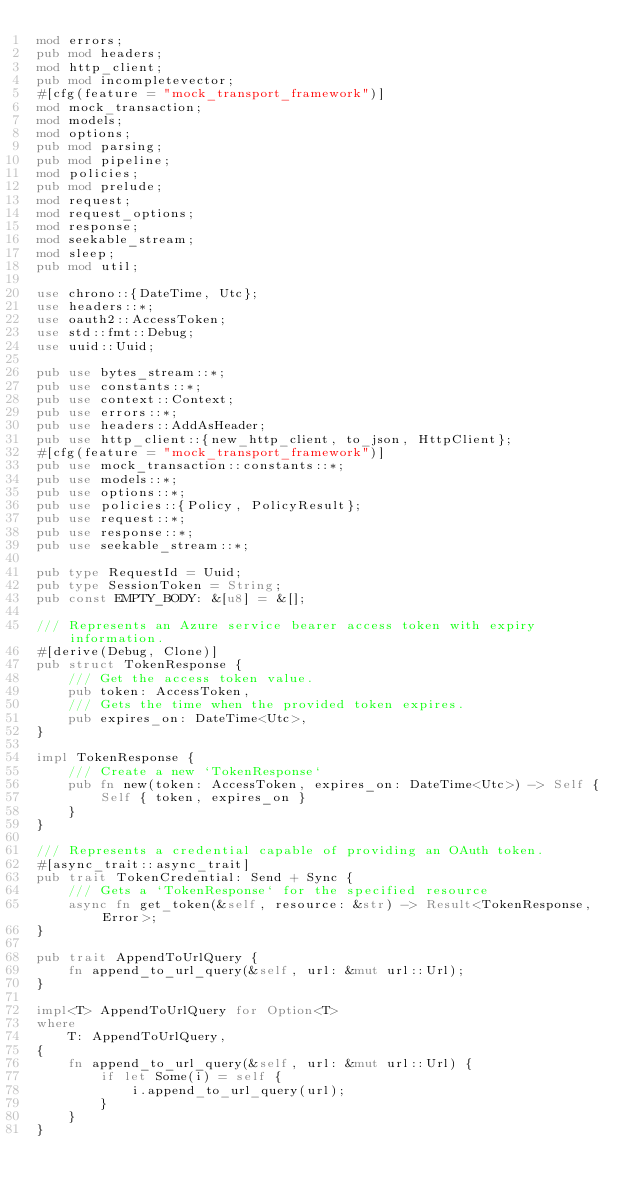<code> <loc_0><loc_0><loc_500><loc_500><_Rust_>mod errors;
pub mod headers;
mod http_client;
pub mod incompletevector;
#[cfg(feature = "mock_transport_framework")]
mod mock_transaction;
mod models;
mod options;
pub mod parsing;
pub mod pipeline;
mod policies;
pub mod prelude;
mod request;
mod request_options;
mod response;
mod seekable_stream;
mod sleep;
pub mod util;

use chrono::{DateTime, Utc};
use headers::*;
use oauth2::AccessToken;
use std::fmt::Debug;
use uuid::Uuid;

pub use bytes_stream::*;
pub use constants::*;
pub use context::Context;
pub use errors::*;
pub use headers::AddAsHeader;
pub use http_client::{new_http_client, to_json, HttpClient};
#[cfg(feature = "mock_transport_framework")]
pub use mock_transaction::constants::*;
pub use models::*;
pub use options::*;
pub use policies::{Policy, PolicyResult};
pub use request::*;
pub use response::*;
pub use seekable_stream::*;

pub type RequestId = Uuid;
pub type SessionToken = String;
pub const EMPTY_BODY: &[u8] = &[];

/// Represents an Azure service bearer access token with expiry information.
#[derive(Debug, Clone)]
pub struct TokenResponse {
    /// Get the access token value.
    pub token: AccessToken,
    /// Gets the time when the provided token expires.
    pub expires_on: DateTime<Utc>,
}

impl TokenResponse {
    /// Create a new `TokenResponse`
    pub fn new(token: AccessToken, expires_on: DateTime<Utc>) -> Self {
        Self { token, expires_on }
    }
}

/// Represents a credential capable of providing an OAuth token.
#[async_trait::async_trait]
pub trait TokenCredential: Send + Sync {
    /// Gets a `TokenResponse` for the specified resource
    async fn get_token(&self, resource: &str) -> Result<TokenResponse, Error>;
}

pub trait AppendToUrlQuery {
    fn append_to_url_query(&self, url: &mut url::Url);
}

impl<T> AppendToUrlQuery for Option<T>
where
    T: AppendToUrlQuery,
{
    fn append_to_url_query(&self, url: &mut url::Url) {
        if let Some(i) = self {
            i.append_to_url_query(url);
        }
    }
}
</code> 